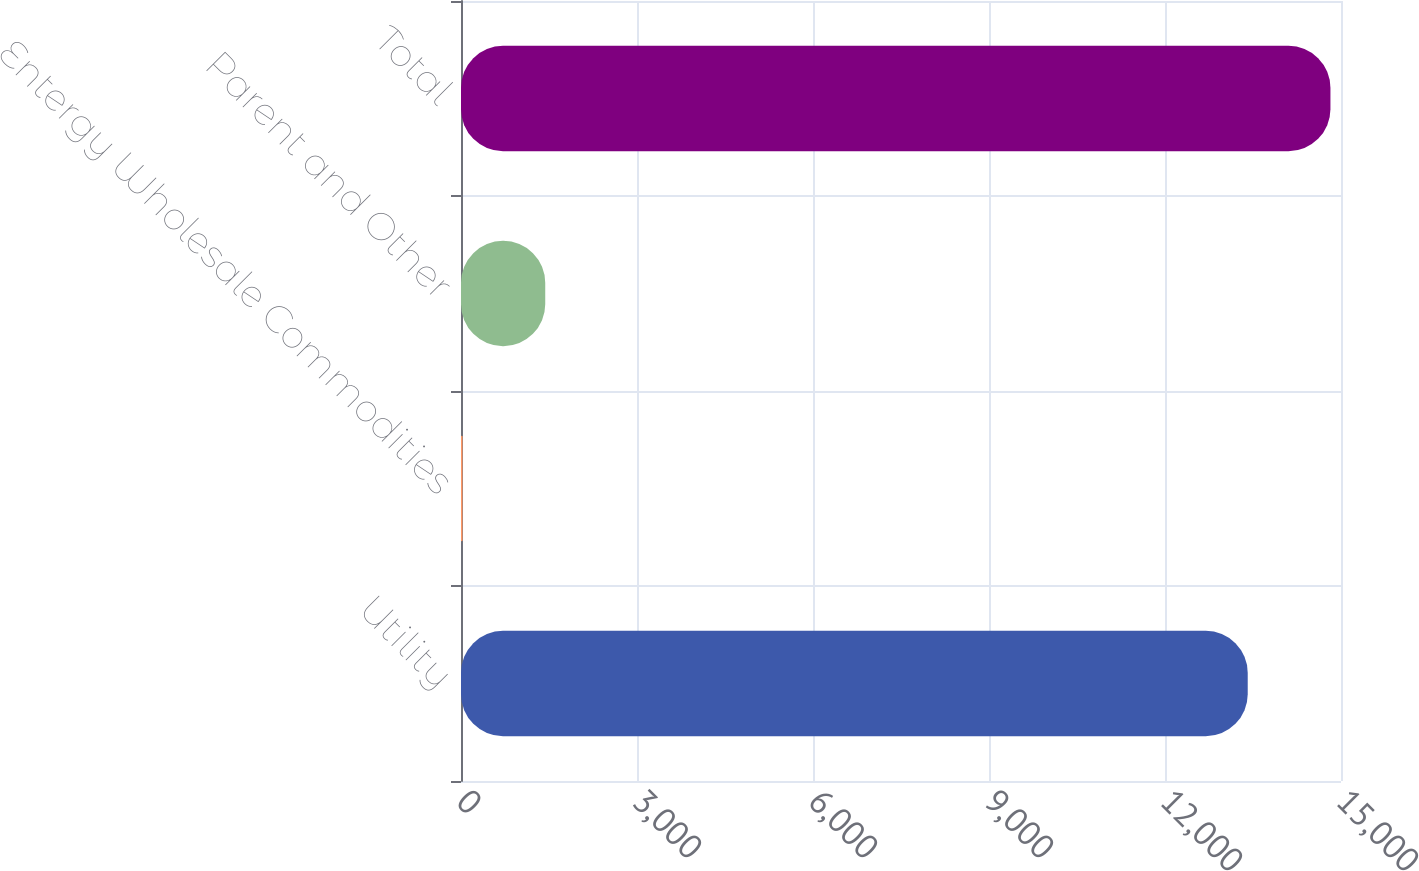Convert chart. <chart><loc_0><loc_0><loc_500><loc_500><bar_chart><fcel>Utility<fcel>Entergy Wholesale Commodities<fcel>Parent and Other<fcel>Total<nl><fcel>13410<fcel>26<fcel>1436<fcel>14820<nl></chart> 